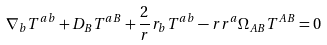Convert formula to latex. <formula><loc_0><loc_0><loc_500><loc_500>\nabla _ { b } T ^ { a b } + D _ { B } T ^ { a B } + \frac { 2 } { r } r _ { b } T ^ { a b } - r r ^ { a } \Omega _ { A B } T ^ { A B } = 0</formula> 